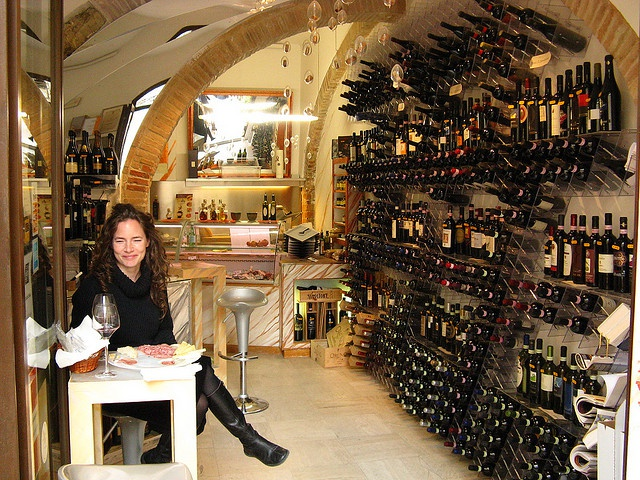Describe the objects in this image and their specific colors. I can see bottle in tan, black, maroon, and olive tones, people in tan, black, and maroon tones, dining table in tan, ivory, black, and khaki tones, dining table in tan and olive tones, and chair in tan, gray, darkgray, and lightgray tones in this image. 